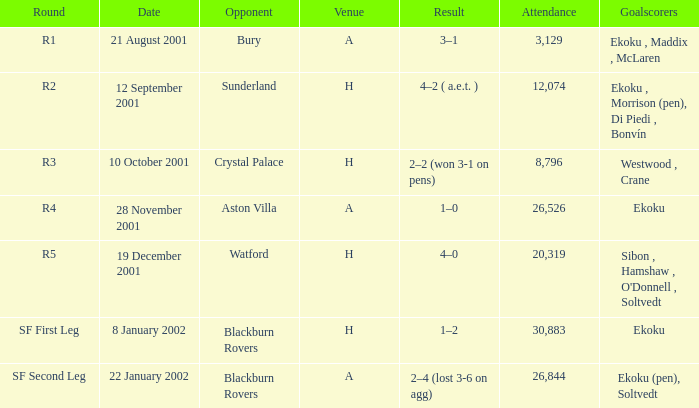Could you parse the entire table as a dict? {'header': ['Round', 'Date', 'Opponent', 'Venue', 'Result', 'Attendance', 'Goalscorers'], 'rows': [['R1', '21 August 2001', 'Bury', 'A', '3–1', '3,129', 'Ekoku , Maddix , McLaren'], ['R2', '12 September 2001', 'Sunderland', 'H', '4–2 ( a.e.t. )', '12,074', 'Ekoku , Morrison (pen), Di Piedi , Bonvín'], ['R3', '10 October 2001', 'Crystal Palace', 'H', '2–2 (won 3-1 on pens)', '8,796', 'Westwood , Crane'], ['R4', '28 November 2001', 'Aston Villa', 'A', '1–0', '26,526', 'Ekoku'], ['R5', '19 December 2001', 'Watford', 'H', '4–0', '20,319', "Sibon , Hamshaw , O'Donnell , Soltvedt"], ['SF First Leg', '8 January 2002', 'Blackburn Rovers', 'H', '1–2', '30,883', 'Ekoku'], ['SF Second Leg', '22 January 2002', 'Blackburn Rovers', 'A', '2–4 (lost 3-6 on agg)', '26,844', 'Ekoku (pen), Soltvedt']]} Which venue has attendance larger than 26,526, and sf first leg round? H. 